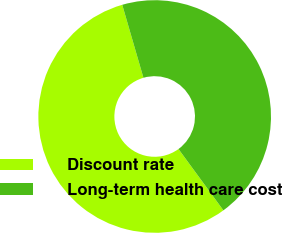<chart> <loc_0><loc_0><loc_500><loc_500><pie_chart><fcel>Discount rate<fcel>Long-term health care cost<nl><fcel>55.56%<fcel>44.44%<nl></chart> 